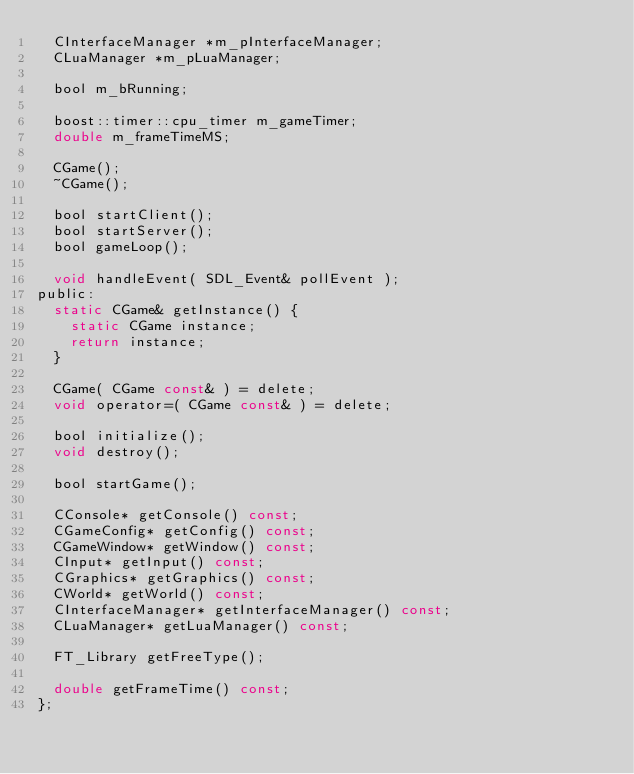Convert code to text. <code><loc_0><loc_0><loc_500><loc_500><_C_>	CInterfaceManager *m_pInterfaceManager;
	CLuaManager *m_pLuaManager;

	bool m_bRunning;

	boost::timer::cpu_timer m_gameTimer;
	double m_frameTimeMS;

	CGame();
	~CGame();

	bool startClient();
	bool startServer();
	bool gameLoop();

	void handleEvent( SDL_Event& pollEvent );
public:
	static CGame& getInstance() {
		static CGame instance;
		return instance;
	}

	CGame( CGame const& ) = delete;
	void operator=( CGame const& ) = delete;

	bool initialize();
	void destroy();

	bool startGame();

	CConsole* getConsole() const;
	CGameConfig* getConfig() const;
	CGameWindow* getWindow() const;
	CInput* getInput() const;
	CGraphics* getGraphics() const;
	CWorld* getWorld() const;
	CInterfaceManager* getInterfaceManager() const;
	CLuaManager* getLuaManager() const;

	FT_Library getFreeType();

	double getFrameTime() const;
};</code> 